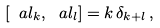<formula> <loc_0><loc_0><loc_500><loc_500>\left [ \ a l _ { k } , \ a l _ { l } \right ] = k \, \delta _ { k + l } \, ,</formula> 